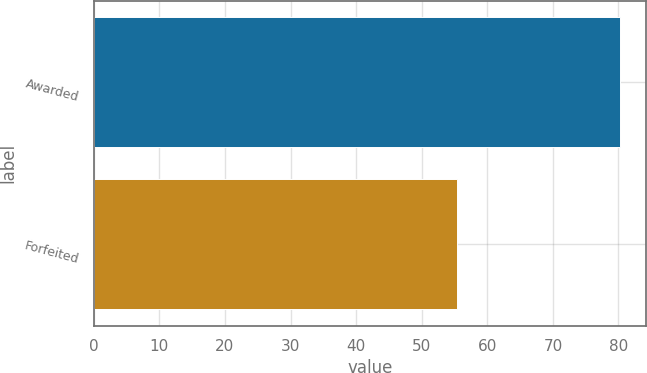Convert chart to OTSL. <chart><loc_0><loc_0><loc_500><loc_500><bar_chart><fcel>Awarded<fcel>Forfeited<nl><fcel>80.24<fcel>55.41<nl></chart> 